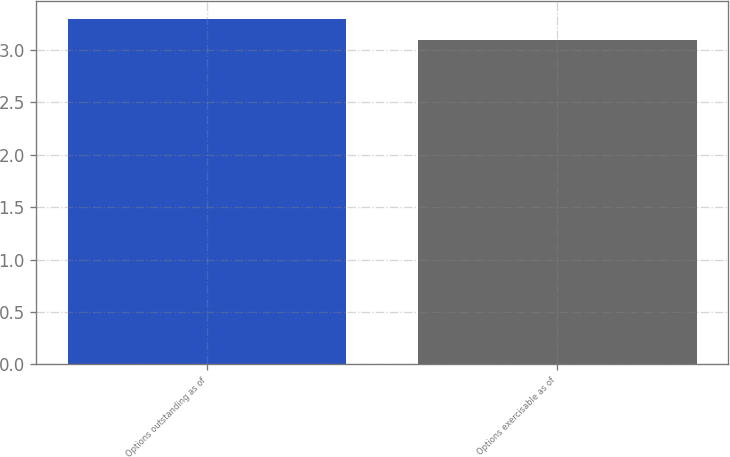Convert chart to OTSL. <chart><loc_0><loc_0><loc_500><loc_500><bar_chart><fcel>Options outstanding as of<fcel>Options exercisable as of<nl><fcel>3.3<fcel>3.1<nl></chart> 